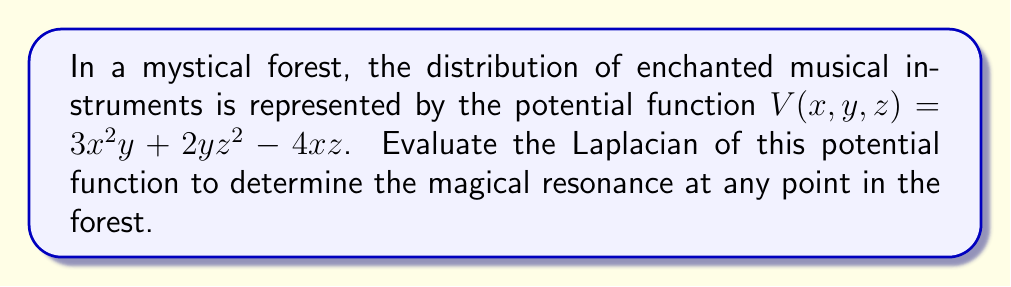Can you answer this question? To evaluate the Laplacian of the potential function, we need to calculate the sum of the second partial derivatives with respect to each variable. The Laplacian in 3D Cartesian coordinates is given by:

$$\nabla^2V = \frac{\partial^2V}{\partial x^2} + \frac{\partial^2V}{\partial y^2} + \frac{\partial^2V}{\partial z^2}$$

Let's calculate each term:

1. $\frac{\partial^2V}{\partial x^2}$:
   First, $\frac{\partial V}{\partial x} = 6xy - 4z$
   Then, $\frac{\partial^2V}{\partial x^2} = 6y$

2. $\frac{\partial^2V}{\partial y^2}$:
   First, $\frac{\partial V}{\partial y} = 3x^2 + 2z^2$
   Then, $\frac{\partial^2V}{\partial y^2} = 0$

3. $\frac{\partial^2V}{\partial z^2}$:
   First, $\frac{\partial V}{\partial z} = 4yz - 4x$
   Then, $\frac{\partial^2V}{\partial z^2} = 4y$

Now, we sum these terms:

$$\nabla^2V = 6y + 0 + 4y = 10y$$

This result shows that the magical resonance at any point in the forest depends only on the y-coordinate, increasing linearly with y.
Answer: $10y$ 